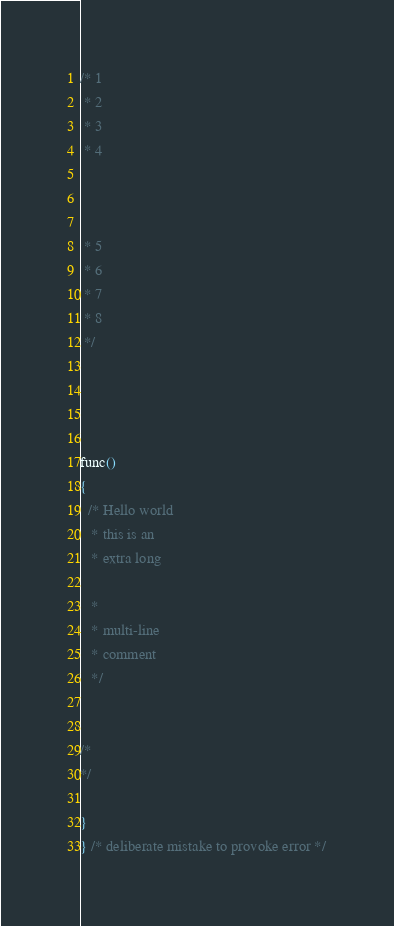<code> <loc_0><loc_0><loc_500><loc_500><_C_>/* 1
 * 2
 * 3
 * 4

  

 * 5
 * 6
 * 7
 * 8
 */

 
  

func()
{
  /* Hello world
   * this is an
   * extra long

   *
   * multi-line
   * comment
   */
 

/*
*/

}
} /* deliberate mistake to provoke error */
</code> 